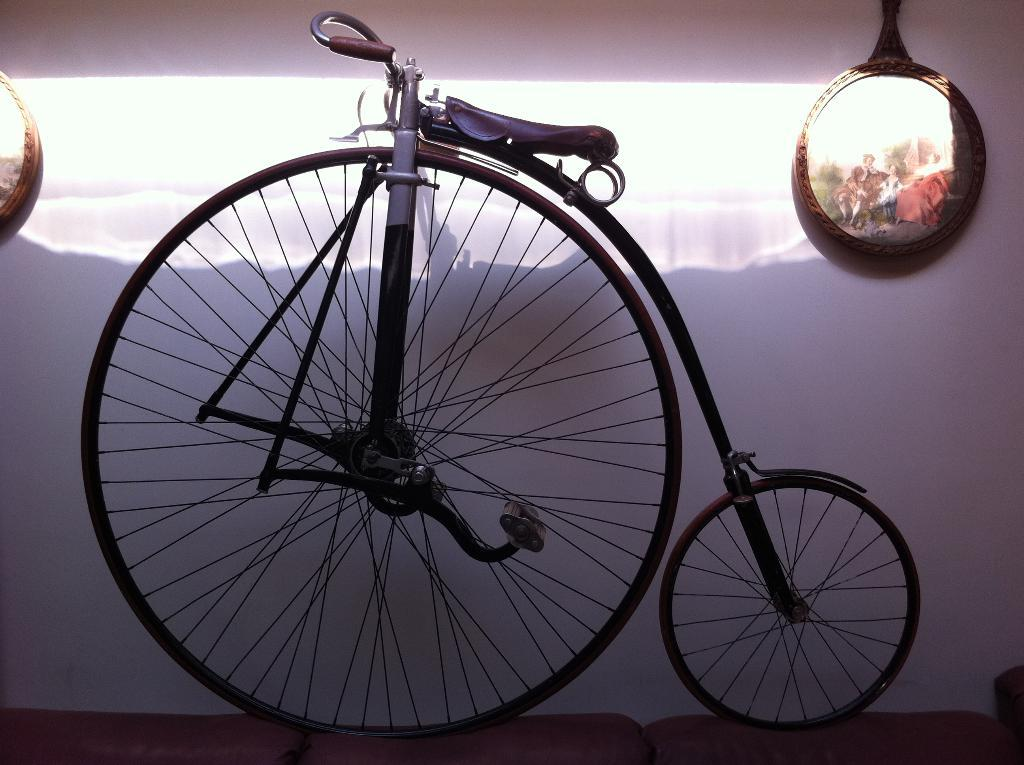What is the main object in the center of the image? There is a bicycle in the center of the image. What can be seen on the wall in the background? There are frames placed on the wall in the background. What is located at the bottom of the image? There is a cloth at the bottom of the image. What type of vest is the boy wearing in the image? There is no boy or vest present in the image. 